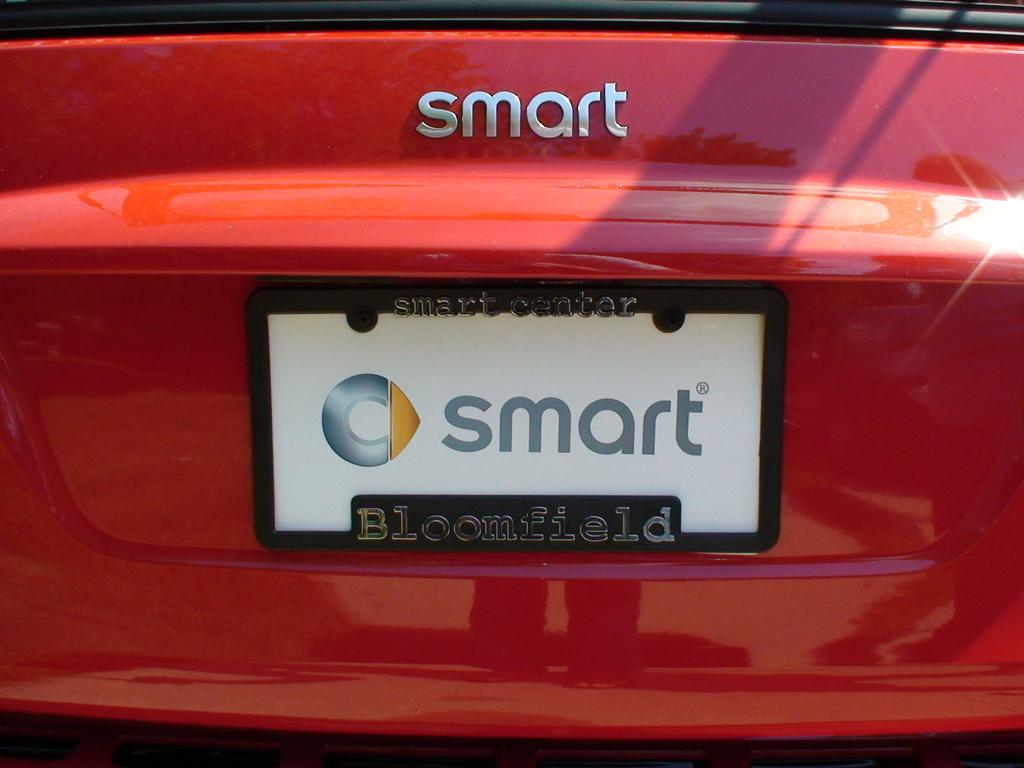<image>
Share a concise interpretation of the image provided. Red car with a license plate which says SMART on it. 